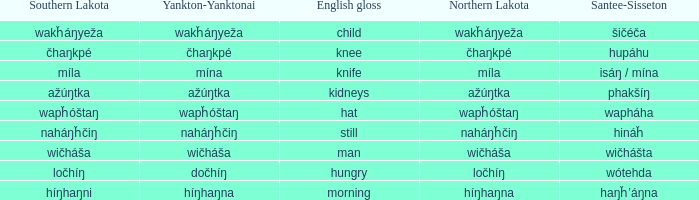Name the number of english gloss for wakȟáŋyeža 1.0. 